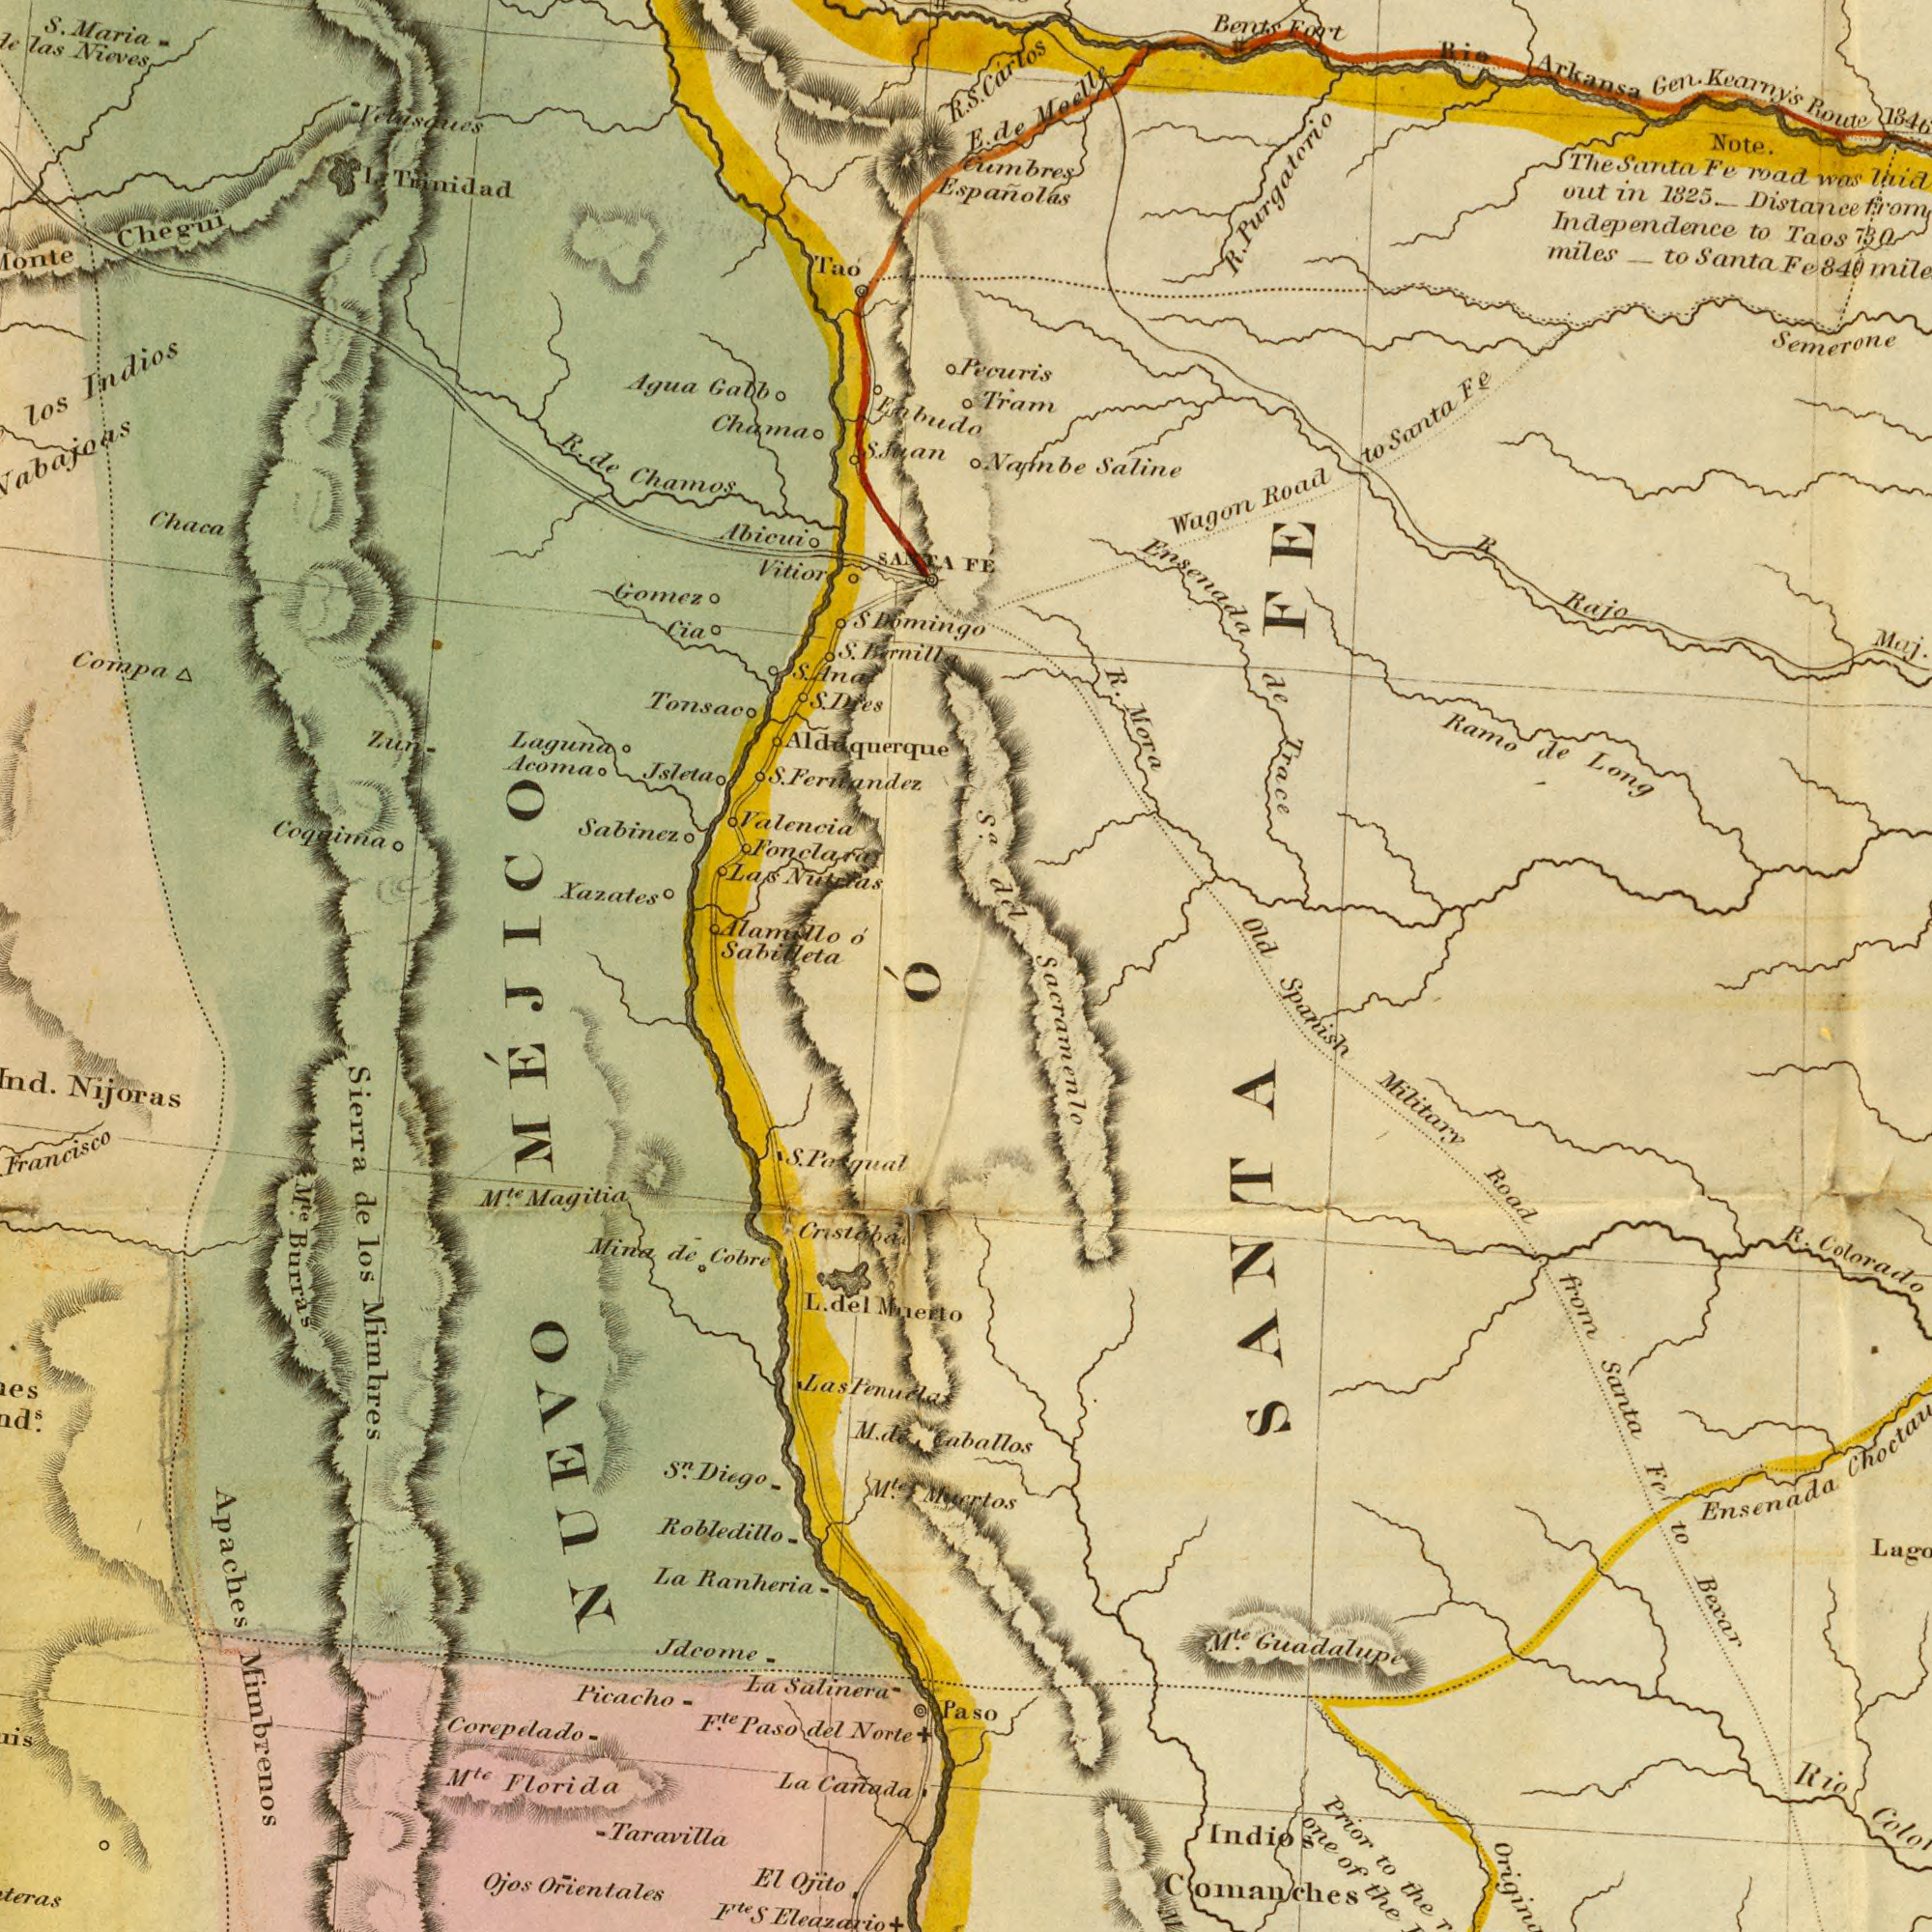What text is shown in the top-left quadrant? Coquima Chamos los S. Ferleandez Xazates Valencia Tonsac Chaca las Chegui Chama Jsleta Trinidad Sabinez Agua Compa Gomez Vitior Nieves Tao Laguna Indios Las Maria Gabb Abicui de R. Enbudo Zun Cia Alamillo S. R. I. Sabilleta Sfuan SANTA S. Domingo S. Ana S. S. Dies Acoma o' What text is visible in the lower-left corner? de de Orientales Florida Magitia Mina Ranheria Picacho Francisco Robledillo Salinera Ojos los Nijoras M<sup>te</sup>. M<sup>te</sup> Eleazario El Apaches Burras M<sup>te</sup>. Cobre Mnerto Corepelado S<sup>n</sup>. Diego S La Taravilla Sierra La F<sup>te</sup>. La Canada de NUEVO Norte Ojito MÉJICO del Jdcome del F<sup>te</sup> Mimbrenos Cristoba Mimhres Paso M<sup>te</sup>. Las S. L. M. Ó Penuclas What text is visible in the lower-right corner? Paso Ensenada Spanish from Military Colorado Guadalupe Prior R. Comanches Rio Road Fe Santa Bexar Indios the SANTA to the to Sacramenlo one of Caballos M<sup>te</sup>. What text is shown in the top-right quadrant? Kearny's R. Note. Purgatorio Mora Rajo Long Carlos Wagon 1825. Fe de Route Tram Santa Ramo miles R. Pecuris Meelle Ensenada Gen. Road road Old Saline FE Bents out Maj. Taos in Nambe Fort was Fe Trace R. to Distance to Arkansa to de 730 The Rio Independence Semerone Cumbres Santa From Santa S. E. de Espanolas S<sup>a</sup>. del Fe 840 FE 